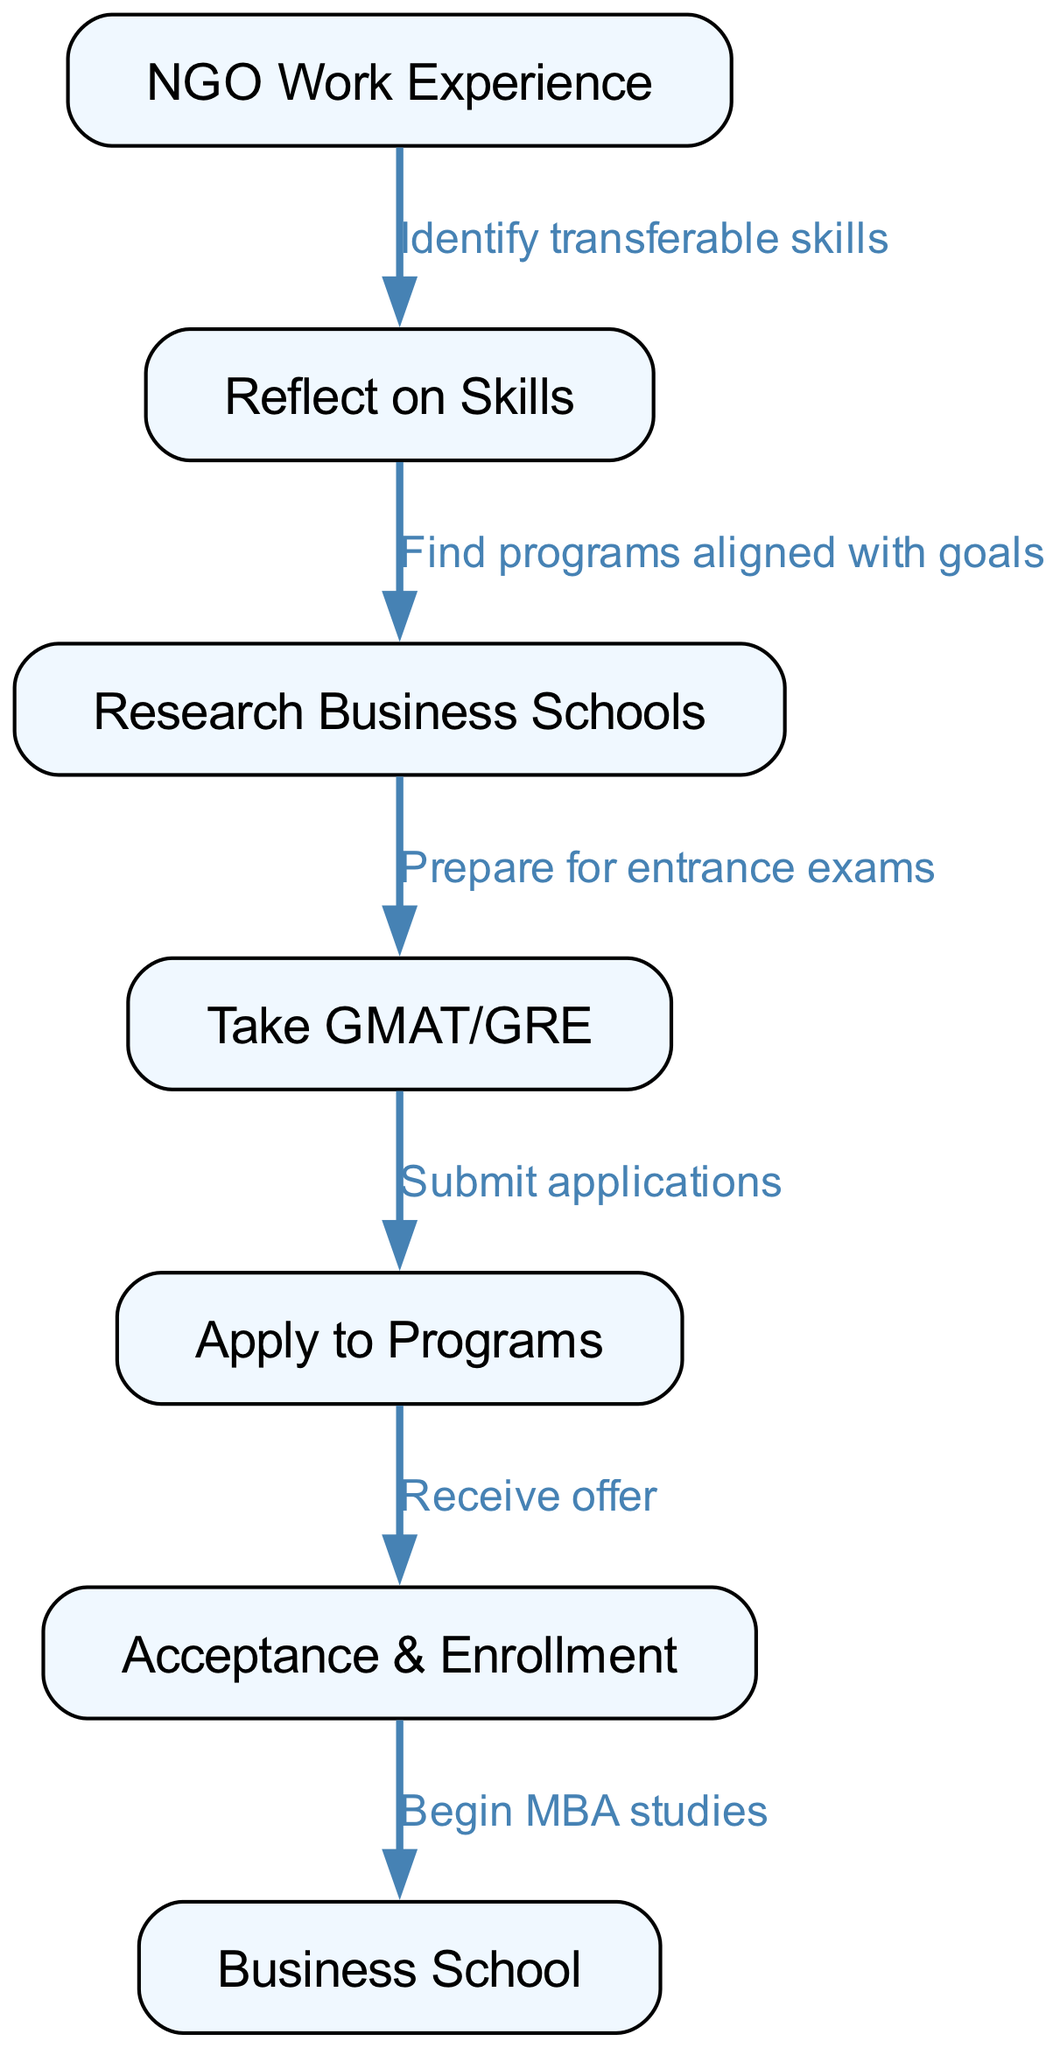What is the first step in the process? The first step in the diagram is represented by the node labeled "NGO Work Experience." This indicates that one starts by having experience in NGO work.
Answer: NGO Work Experience How many nodes are there in the diagram? The diagram contains a total of 7 nodes. Each node represents a step or concept in the transition process. A quick count of the nodes confirms this total.
Answer: 7 What does the edge from "Reflect on Skills" to "Research Business Schools" indicate? The edge indicates a connection where, after reflecting on skills, one should find programs aligned with their goals, implying a logical progression from self-assessment to exploration of business schools.
Answer: Find programs aligned with goals What must you do after taking the GMAT/GRE? After taking the GMAT/GRE, the next step in the process is to submit applications to business school programs. This follows the examination requirement necessary for application.
Answer: Submit applications What is the last step in the transition to business school? The last step in the process is "Begin MBA studies," which is the point of starting the educational journey at business school after acceptance and enrollment.
Answer: Begin MBA studies How does one move from “NGO Work Experience” to “Research Business Schools”? One moves from "NGO Work Experience" to "Research Business Schools" by reflecting on skills gained in the previous work and finding business programs that align with their career goals. This involves both introspection and external research.
Answer: Find programs aligned with goals What is the connecting action to go from “Acceptances & Enrollment” to “Business School”? The connecting action from "Acceptances & Enrollment" to "Business School" is to begin MBA studies, indicating the final transition from acceptance into actual academic participation.
Answer: Begin MBA studies Which edge represents the requirement for entrance exams? The edge connecting "Research Business Schools" to "Take GMAT/GRE" represents the requirement to prepare for entrance exams before applying to programs. This signifies the steps needed for application readiness.
Answer: Prepare for entrance exams 